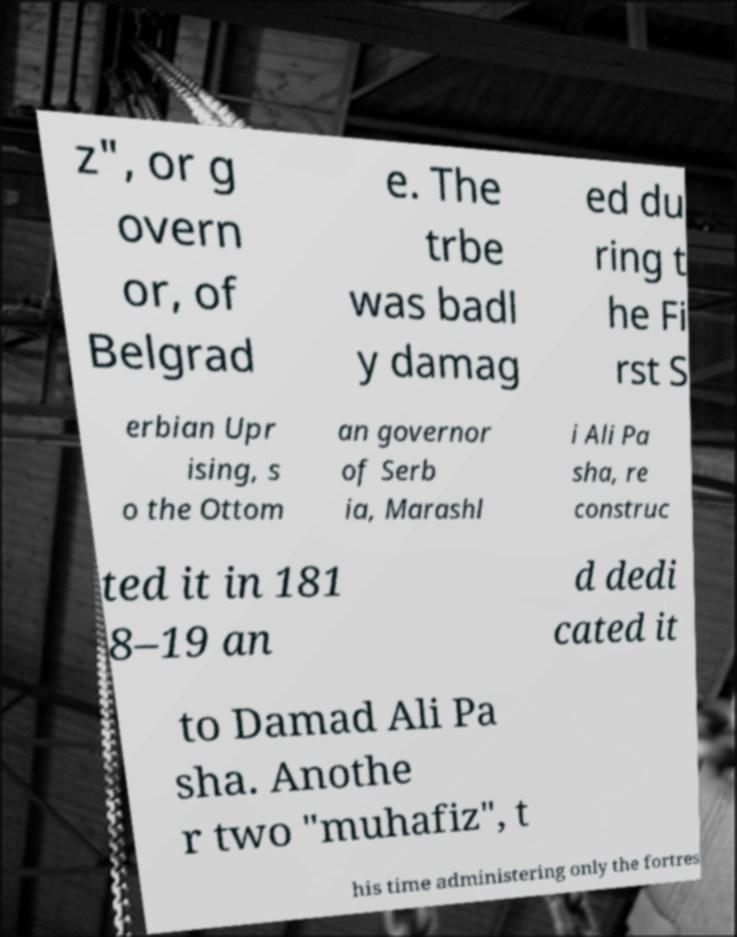There's text embedded in this image that I need extracted. Can you transcribe it verbatim? z", or g overn or, of Belgrad e. The trbe was badl y damag ed du ring t he Fi rst S erbian Upr ising, s o the Ottom an governor of Serb ia, Marashl i Ali Pa sha, re construc ted it in 181 8–19 an d dedi cated it to Damad Ali Pa sha. Anothe r two "muhafiz", t his time administering only the fortres 